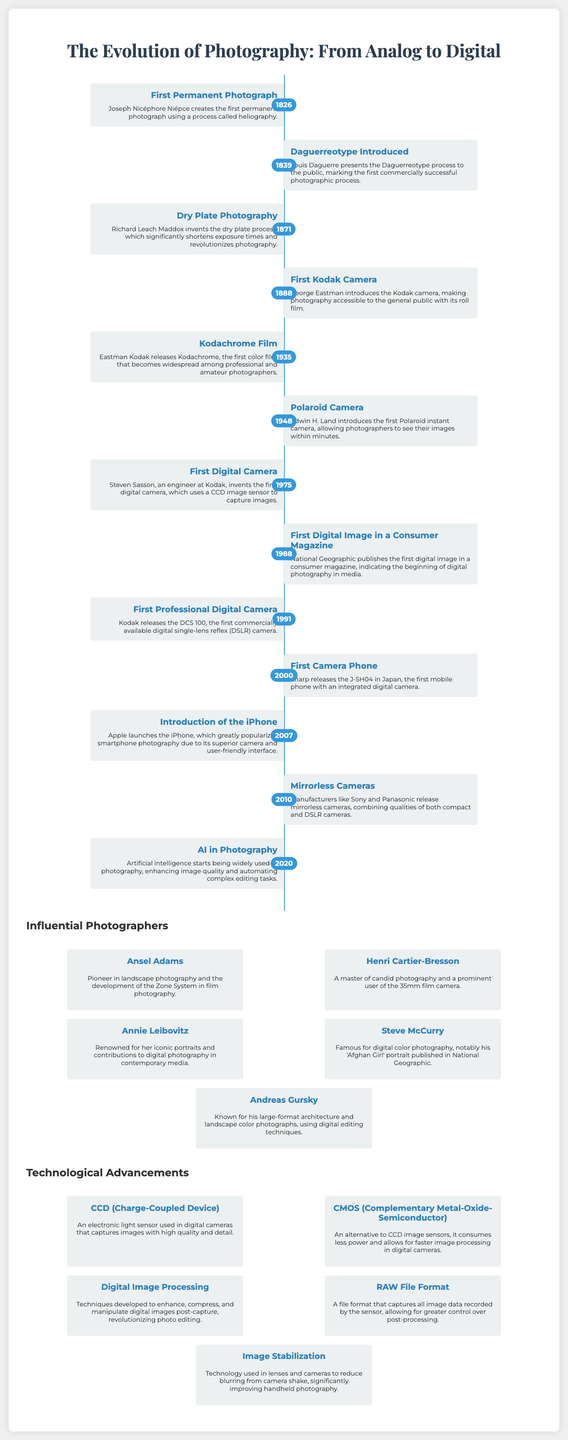What year was the first permanent photograph created? The timeline indicates that the first permanent photograph was created in 1826.
Answer: 1826 Who introduced the Kodak camera? The timeline states that George Eastman introduced the Kodak camera in 1888.
Answer: George Eastman What major photographic process was introduced in 1839? The timeline mentions the introduction of the Daguerreotype process to the public in 1839.
Answer: Daguerreotype What innovation did Steven Sasson create in 1975? The timeline highlights that Steven Sasson invented the first digital camera in 1975.
Answer: First digital camera Which influential photographer is renowned for iconic portraits? The document lists Annie Leibovitz as renowned for her iconic portraits.
Answer: Annie Leibovitz What technological advancement focuses on reducing camera shake? The advancements section mentions image stabilization as the technology used to reduce blurring from camera shake.
Answer: Image Stabilization What year did the iPhone launch? According to the timeline, the iPhone was launched in 2007.
Answer: 2007 Who was a pioneer in landscape photography? The document indicates that Ansel Adams was a pioneer in landscape photography.
Answer: Ansel Adams What sensor is used in digital cameras for capturing images? The advancements section states that CCD (Charge-Coupled Device) is used in digital cameras.
Answer: CCD 